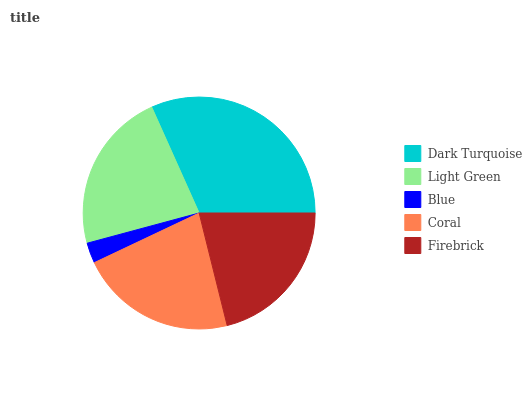Is Blue the minimum?
Answer yes or no. Yes. Is Dark Turquoise the maximum?
Answer yes or no. Yes. Is Light Green the minimum?
Answer yes or no. No. Is Light Green the maximum?
Answer yes or no. No. Is Dark Turquoise greater than Light Green?
Answer yes or no. Yes. Is Light Green less than Dark Turquoise?
Answer yes or no. Yes. Is Light Green greater than Dark Turquoise?
Answer yes or no. No. Is Dark Turquoise less than Light Green?
Answer yes or no. No. Is Coral the high median?
Answer yes or no. Yes. Is Coral the low median?
Answer yes or no. Yes. Is Light Green the high median?
Answer yes or no. No. Is Dark Turquoise the low median?
Answer yes or no. No. 